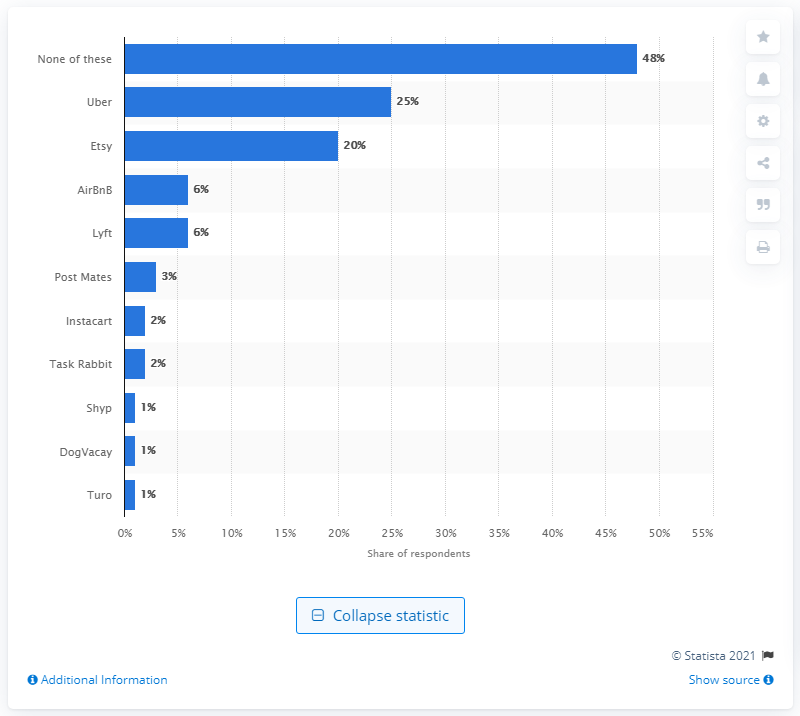Specify some key components in this picture. According to a survey, 20% of respondents reported using Etsy, a social commerce platform, in the past year. 